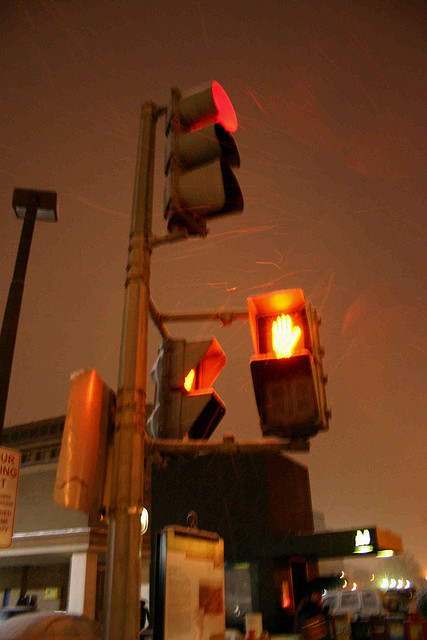Is that a forest in the background? No, there is no forest visible in the background. The scene features urban elements like roads, traffic signs, and lights, typical of a cityscape setting. 